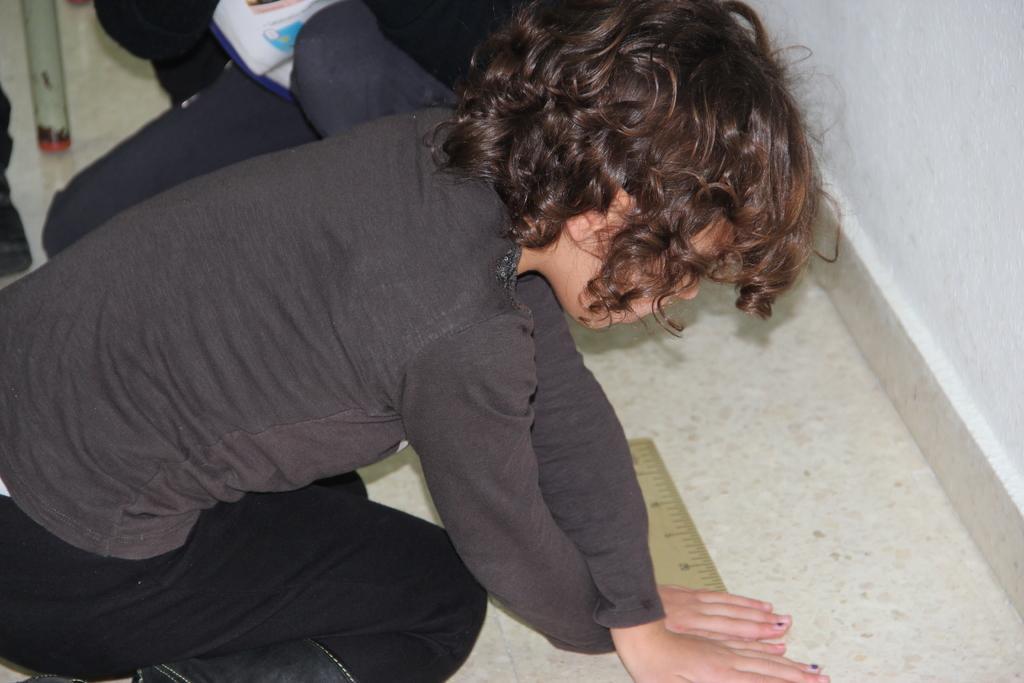Can you describe this image briefly? In this image there is one kid is holding a wooden scale as we can see at left side of this image and there is a wall at right side of this image and there is a floor as we can see at bottom of this image. 